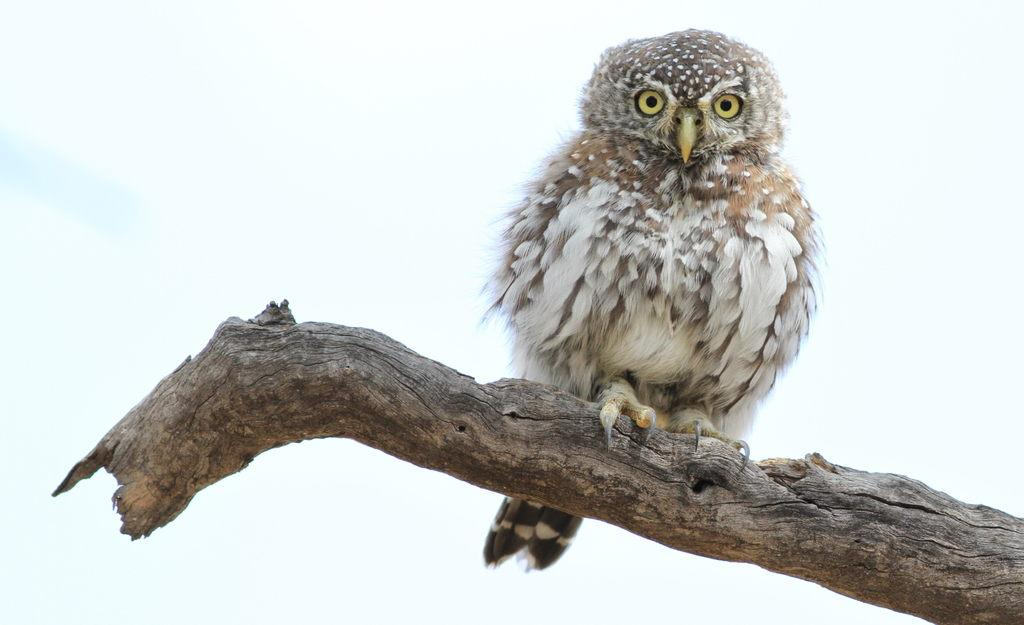What is depicted on the bark in the image? There is an owl representation on the bark in the image. What type of meal is being prepared using the potato in the image? There is no potato or meal preparation present in the image; it features an owl representation on the bark. 